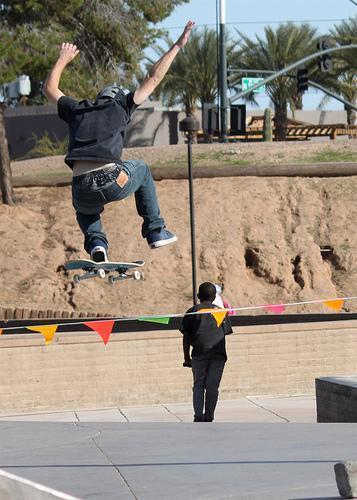How many people?
Give a very brief answer. 2. 